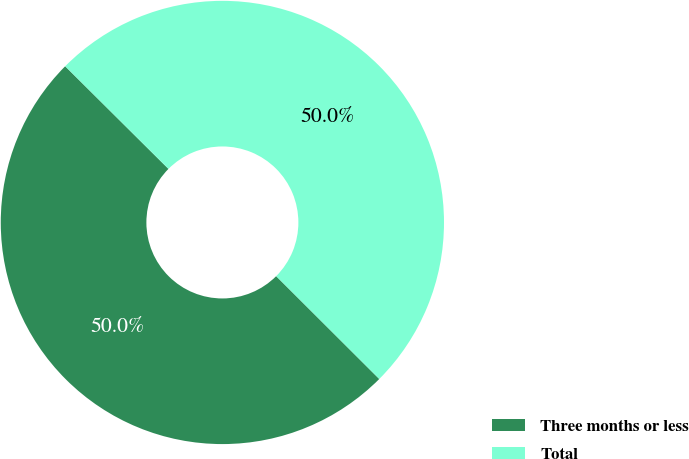Convert chart. <chart><loc_0><loc_0><loc_500><loc_500><pie_chart><fcel>Three months or less<fcel>Total<nl><fcel>49.97%<fcel>50.03%<nl></chart> 